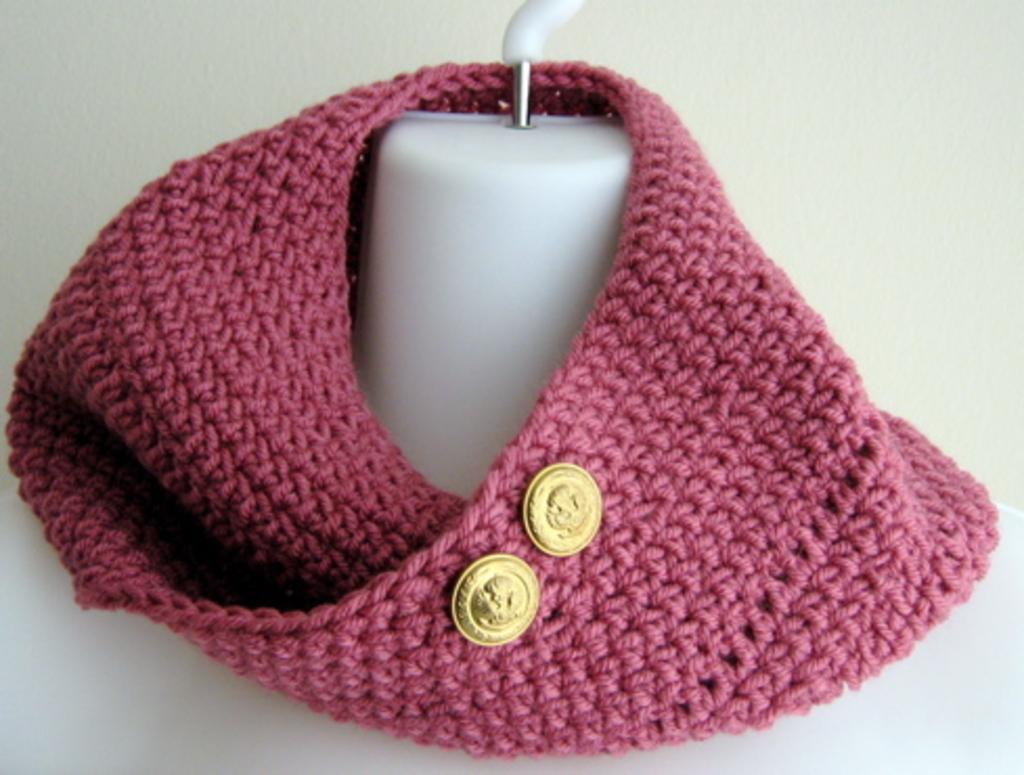How would you summarize this image in a sentence or two? In this picture we can observe a mannequin. There is a pink color cloth around the neck of the mannequin. We can observe two gold color buttons. The background is in white color. 